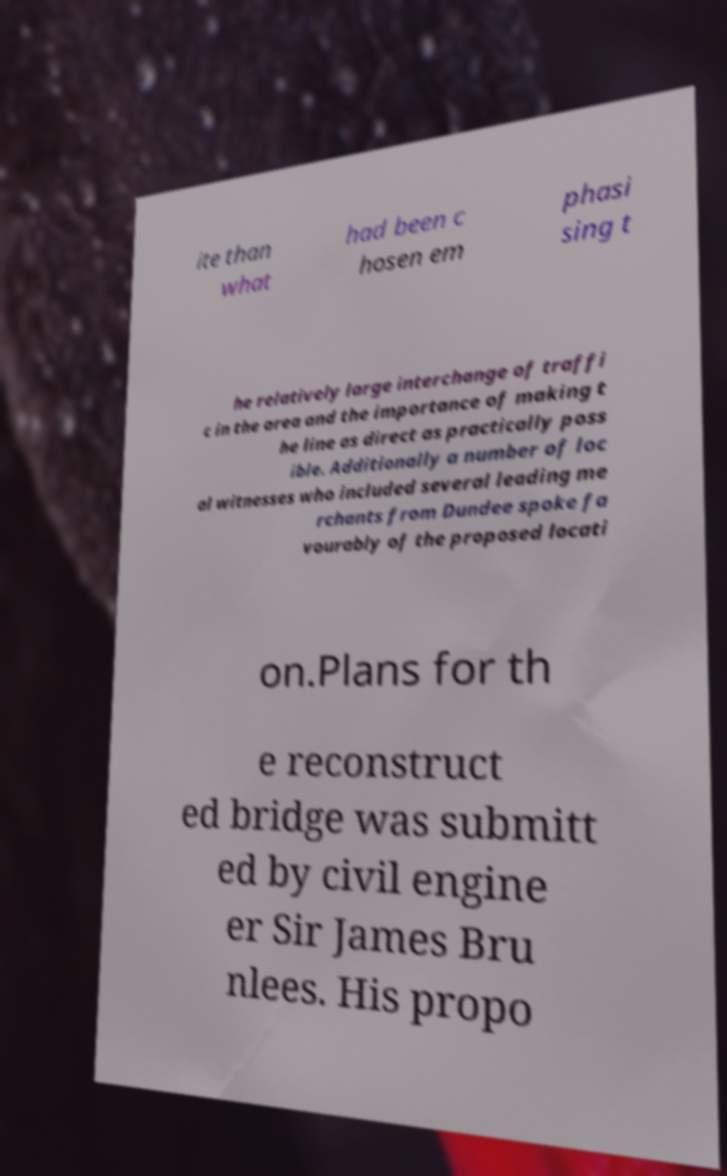Can you read and provide the text displayed in the image?This photo seems to have some interesting text. Can you extract and type it out for me? ite than what had been c hosen em phasi sing t he relatively large interchange of traffi c in the area and the importance of making t he line as direct as practically poss ible. Additionally a number of loc al witnesses who included several leading me rchants from Dundee spoke fa vourably of the proposed locati on.Plans for th e reconstruct ed bridge was submitt ed by civil engine er Sir James Bru nlees. His propo 